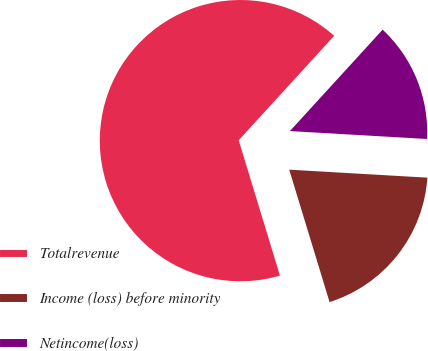Convert chart to OTSL. <chart><loc_0><loc_0><loc_500><loc_500><pie_chart><fcel>Totalrevenue<fcel>Income (loss) before minority<fcel>Netincome(loss)<nl><fcel>66.49%<fcel>19.37%<fcel>14.13%<nl></chart> 